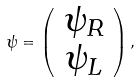Convert formula to latex. <formula><loc_0><loc_0><loc_500><loc_500>\psi = \left ( \begin{array} { c } \psi _ { R } \\ \psi _ { L } \end{array} \right ) ,</formula> 